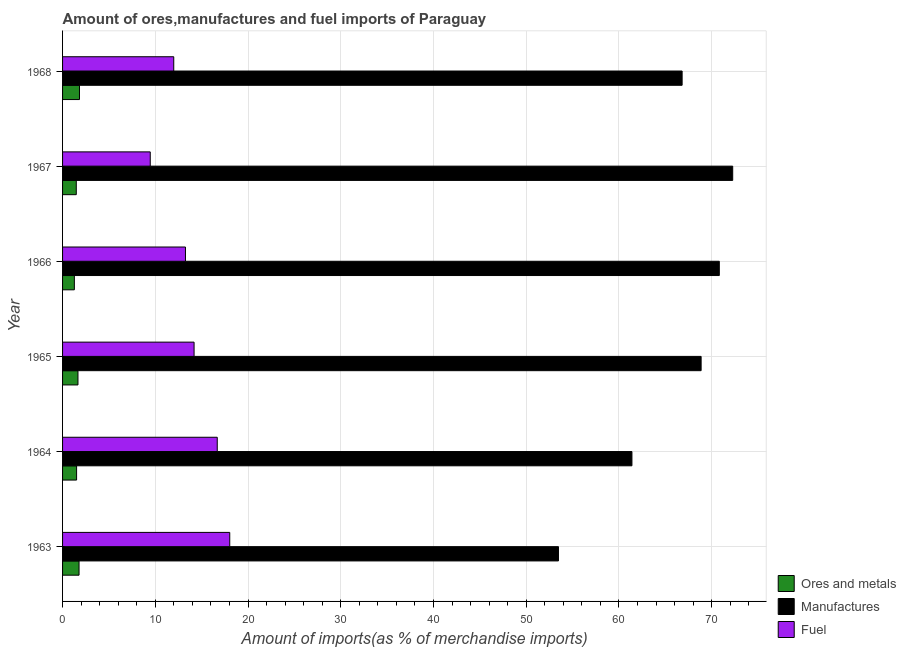Are the number of bars on each tick of the Y-axis equal?
Provide a short and direct response. Yes. How many bars are there on the 2nd tick from the top?
Make the answer very short. 3. What is the label of the 1st group of bars from the top?
Provide a succinct answer. 1968. In how many cases, is the number of bars for a given year not equal to the number of legend labels?
Offer a very short reply. 0. What is the percentage of manufactures imports in 1964?
Provide a short and direct response. 61.4. Across all years, what is the maximum percentage of ores and metals imports?
Your response must be concise. 1.82. Across all years, what is the minimum percentage of manufactures imports?
Provide a short and direct response. 53.48. In which year was the percentage of ores and metals imports maximum?
Provide a short and direct response. 1968. In which year was the percentage of manufactures imports minimum?
Provide a short and direct response. 1963. What is the total percentage of fuel imports in the graph?
Provide a succinct answer. 83.59. What is the difference between the percentage of manufactures imports in 1963 and that in 1967?
Offer a terse response. -18.79. What is the difference between the percentage of fuel imports in 1963 and the percentage of ores and metals imports in 1967?
Give a very brief answer. 16.55. What is the average percentage of fuel imports per year?
Offer a very short reply. 13.93. In the year 1968, what is the difference between the percentage of manufactures imports and percentage of fuel imports?
Your answer should be compact. 54.83. In how many years, is the percentage of manufactures imports greater than 32 %?
Offer a very short reply. 6. What is the ratio of the percentage of ores and metals imports in 1966 to that in 1967?
Offer a terse response. 0.86. Is the difference between the percentage of fuel imports in 1966 and 1968 greater than the difference between the percentage of manufactures imports in 1966 and 1968?
Offer a very short reply. No. What is the difference between the highest and the second highest percentage of ores and metals imports?
Ensure brevity in your answer.  0.05. What is the difference between the highest and the lowest percentage of ores and metals imports?
Your answer should be compact. 0.55. In how many years, is the percentage of fuel imports greater than the average percentage of fuel imports taken over all years?
Give a very brief answer. 3. Is the sum of the percentage of ores and metals imports in 1966 and 1967 greater than the maximum percentage of manufactures imports across all years?
Your answer should be very brief. No. What does the 3rd bar from the top in 1965 represents?
Give a very brief answer. Ores and metals. What does the 2nd bar from the bottom in 1968 represents?
Your answer should be compact. Manufactures. Is it the case that in every year, the sum of the percentage of ores and metals imports and percentage of manufactures imports is greater than the percentage of fuel imports?
Provide a short and direct response. Yes. What is the difference between two consecutive major ticks on the X-axis?
Provide a succinct answer. 10. Does the graph contain grids?
Ensure brevity in your answer.  Yes. Where does the legend appear in the graph?
Provide a short and direct response. Bottom right. How many legend labels are there?
Keep it short and to the point. 3. How are the legend labels stacked?
Ensure brevity in your answer.  Vertical. What is the title of the graph?
Offer a very short reply. Amount of ores,manufactures and fuel imports of Paraguay. Does "Grants" appear as one of the legend labels in the graph?
Keep it short and to the point. No. What is the label or title of the X-axis?
Give a very brief answer. Amount of imports(as % of merchandise imports). What is the label or title of the Y-axis?
Provide a short and direct response. Year. What is the Amount of imports(as % of merchandise imports) of Ores and metals in 1963?
Your response must be concise. 1.78. What is the Amount of imports(as % of merchandise imports) in Manufactures in 1963?
Ensure brevity in your answer.  53.48. What is the Amount of imports(as % of merchandise imports) of Fuel in 1963?
Ensure brevity in your answer.  18.03. What is the Amount of imports(as % of merchandise imports) of Ores and metals in 1964?
Your answer should be very brief. 1.51. What is the Amount of imports(as % of merchandise imports) of Manufactures in 1964?
Provide a short and direct response. 61.4. What is the Amount of imports(as % of merchandise imports) of Fuel in 1964?
Your answer should be compact. 16.68. What is the Amount of imports(as % of merchandise imports) in Ores and metals in 1965?
Provide a short and direct response. 1.66. What is the Amount of imports(as % of merchandise imports) in Manufactures in 1965?
Keep it short and to the point. 68.86. What is the Amount of imports(as % of merchandise imports) in Fuel in 1965?
Make the answer very short. 14.18. What is the Amount of imports(as % of merchandise imports) in Ores and metals in 1966?
Keep it short and to the point. 1.27. What is the Amount of imports(as % of merchandise imports) in Manufactures in 1966?
Keep it short and to the point. 70.83. What is the Amount of imports(as % of merchandise imports) of Fuel in 1966?
Provide a short and direct response. 13.25. What is the Amount of imports(as % of merchandise imports) of Ores and metals in 1967?
Offer a very short reply. 1.48. What is the Amount of imports(as % of merchandise imports) in Manufactures in 1967?
Offer a very short reply. 72.27. What is the Amount of imports(as % of merchandise imports) of Fuel in 1967?
Give a very brief answer. 9.46. What is the Amount of imports(as % of merchandise imports) in Ores and metals in 1968?
Your answer should be very brief. 1.82. What is the Amount of imports(as % of merchandise imports) in Manufactures in 1968?
Make the answer very short. 66.82. What is the Amount of imports(as % of merchandise imports) in Fuel in 1968?
Ensure brevity in your answer.  11.99. Across all years, what is the maximum Amount of imports(as % of merchandise imports) in Ores and metals?
Ensure brevity in your answer.  1.82. Across all years, what is the maximum Amount of imports(as % of merchandise imports) in Manufactures?
Provide a succinct answer. 72.27. Across all years, what is the maximum Amount of imports(as % of merchandise imports) of Fuel?
Make the answer very short. 18.03. Across all years, what is the minimum Amount of imports(as % of merchandise imports) of Ores and metals?
Offer a terse response. 1.27. Across all years, what is the minimum Amount of imports(as % of merchandise imports) of Manufactures?
Your response must be concise. 53.48. Across all years, what is the minimum Amount of imports(as % of merchandise imports) of Fuel?
Offer a very short reply. 9.46. What is the total Amount of imports(as % of merchandise imports) in Ores and metals in the graph?
Keep it short and to the point. 9.53. What is the total Amount of imports(as % of merchandise imports) in Manufactures in the graph?
Your answer should be compact. 393.66. What is the total Amount of imports(as % of merchandise imports) of Fuel in the graph?
Keep it short and to the point. 83.59. What is the difference between the Amount of imports(as % of merchandise imports) in Ores and metals in 1963 and that in 1964?
Keep it short and to the point. 0.26. What is the difference between the Amount of imports(as % of merchandise imports) in Manufactures in 1963 and that in 1964?
Offer a terse response. -7.92. What is the difference between the Amount of imports(as % of merchandise imports) in Fuel in 1963 and that in 1964?
Your answer should be very brief. 1.35. What is the difference between the Amount of imports(as % of merchandise imports) in Ores and metals in 1963 and that in 1965?
Offer a very short reply. 0.12. What is the difference between the Amount of imports(as % of merchandise imports) of Manufactures in 1963 and that in 1965?
Offer a very short reply. -15.38. What is the difference between the Amount of imports(as % of merchandise imports) of Fuel in 1963 and that in 1965?
Your answer should be compact. 3.85. What is the difference between the Amount of imports(as % of merchandise imports) of Ores and metals in 1963 and that in 1966?
Give a very brief answer. 0.5. What is the difference between the Amount of imports(as % of merchandise imports) in Manufactures in 1963 and that in 1966?
Your answer should be compact. -17.35. What is the difference between the Amount of imports(as % of merchandise imports) in Fuel in 1963 and that in 1966?
Your response must be concise. 4.78. What is the difference between the Amount of imports(as % of merchandise imports) in Ores and metals in 1963 and that in 1967?
Make the answer very short. 0.3. What is the difference between the Amount of imports(as % of merchandise imports) of Manufactures in 1963 and that in 1967?
Keep it short and to the point. -18.79. What is the difference between the Amount of imports(as % of merchandise imports) of Fuel in 1963 and that in 1967?
Offer a very short reply. 8.57. What is the difference between the Amount of imports(as % of merchandise imports) in Ores and metals in 1963 and that in 1968?
Keep it short and to the point. -0.05. What is the difference between the Amount of imports(as % of merchandise imports) of Manufactures in 1963 and that in 1968?
Offer a terse response. -13.34. What is the difference between the Amount of imports(as % of merchandise imports) of Fuel in 1963 and that in 1968?
Your response must be concise. 6.04. What is the difference between the Amount of imports(as % of merchandise imports) of Ores and metals in 1964 and that in 1965?
Your answer should be compact. -0.15. What is the difference between the Amount of imports(as % of merchandise imports) in Manufactures in 1964 and that in 1965?
Offer a terse response. -7.46. What is the difference between the Amount of imports(as % of merchandise imports) in Fuel in 1964 and that in 1965?
Your answer should be very brief. 2.5. What is the difference between the Amount of imports(as % of merchandise imports) of Ores and metals in 1964 and that in 1966?
Offer a very short reply. 0.24. What is the difference between the Amount of imports(as % of merchandise imports) of Manufactures in 1964 and that in 1966?
Make the answer very short. -9.42. What is the difference between the Amount of imports(as % of merchandise imports) of Fuel in 1964 and that in 1966?
Offer a terse response. 3.43. What is the difference between the Amount of imports(as % of merchandise imports) in Ores and metals in 1964 and that in 1967?
Your answer should be very brief. 0.03. What is the difference between the Amount of imports(as % of merchandise imports) in Manufactures in 1964 and that in 1967?
Your response must be concise. -10.87. What is the difference between the Amount of imports(as % of merchandise imports) of Fuel in 1964 and that in 1967?
Keep it short and to the point. 7.23. What is the difference between the Amount of imports(as % of merchandise imports) of Ores and metals in 1964 and that in 1968?
Keep it short and to the point. -0.31. What is the difference between the Amount of imports(as % of merchandise imports) of Manufactures in 1964 and that in 1968?
Provide a short and direct response. -5.41. What is the difference between the Amount of imports(as % of merchandise imports) in Fuel in 1964 and that in 1968?
Ensure brevity in your answer.  4.69. What is the difference between the Amount of imports(as % of merchandise imports) in Ores and metals in 1965 and that in 1966?
Your answer should be very brief. 0.39. What is the difference between the Amount of imports(as % of merchandise imports) of Manufactures in 1965 and that in 1966?
Offer a terse response. -1.96. What is the difference between the Amount of imports(as % of merchandise imports) of Fuel in 1965 and that in 1966?
Ensure brevity in your answer.  0.93. What is the difference between the Amount of imports(as % of merchandise imports) in Ores and metals in 1965 and that in 1967?
Provide a short and direct response. 0.18. What is the difference between the Amount of imports(as % of merchandise imports) of Manufactures in 1965 and that in 1967?
Ensure brevity in your answer.  -3.41. What is the difference between the Amount of imports(as % of merchandise imports) in Fuel in 1965 and that in 1967?
Your response must be concise. 4.73. What is the difference between the Amount of imports(as % of merchandise imports) of Ores and metals in 1965 and that in 1968?
Make the answer very short. -0.16. What is the difference between the Amount of imports(as % of merchandise imports) of Manufactures in 1965 and that in 1968?
Offer a very short reply. 2.05. What is the difference between the Amount of imports(as % of merchandise imports) of Fuel in 1965 and that in 1968?
Ensure brevity in your answer.  2.19. What is the difference between the Amount of imports(as % of merchandise imports) of Ores and metals in 1966 and that in 1967?
Provide a succinct answer. -0.21. What is the difference between the Amount of imports(as % of merchandise imports) of Manufactures in 1966 and that in 1967?
Make the answer very short. -1.44. What is the difference between the Amount of imports(as % of merchandise imports) in Fuel in 1966 and that in 1967?
Make the answer very short. 3.8. What is the difference between the Amount of imports(as % of merchandise imports) of Ores and metals in 1966 and that in 1968?
Offer a very short reply. -0.55. What is the difference between the Amount of imports(as % of merchandise imports) of Manufactures in 1966 and that in 1968?
Provide a succinct answer. 4.01. What is the difference between the Amount of imports(as % of merchandise imports) in Fuel in 1966 and that in 1968?
Your answer should be compact. 1.26. What is the difference between the Amount of imports(as % of merchandise imports) in Ores and metals in 1967 and that in 1968?
Give a very brief answer. -0.35. What is the difference between the Amount of imports(as % of merchandise imports) of Manufactures in 1967 and that in 1968?
Provide a succinct answer. 5.45. What is the difference between the Amount of imports(as % of merchandise imports) of Fuel in 1967 and that in 1968?
Provide a succinct answer. -2.53. What is the difference between the Amount of imports(as % of merchandise imports) in Ores and metals in 1963 and the Amount of imports(as % of merchandise imports) in Manufactures in 1964?
Your response must be concise. -59.63. What is the difference between the Amount of imports(as % of merchandise imports) of Ores and metals in 1963 and the Amount of imports(as % of merchandise imports) of Fuel in 1964?
Your response must be concise. -14.9. What is the difference between the Amount of imports(as % of merchandise imports) in Manufactures in 1963 and the Amount of imports(as % of merchandise imports) in Fuel in 1964?
Give a very brief answer. 36.8. What is the difference between the Amount of imports(as % of merchandise imports) in Ores and metals in 1963 and the Amount of imports(as % of merchandise imports) in Manufactures in 1965?
Provide a succinct answer. -67.09. What is the difference between the Amount of imports(as % of merchandise imports) in Ores and metals in 1963 and the Amount of imports(as % of merchandise imports) in Fuel in 1965?
Your answer should be very brief. -12.41. What is the difference between the Amount of imports(as % of merchandise imports) in Manufactures in 1963 and the Amount of imports(as % of merchandise imports) in Fuel in 1965?
Offer a terse response. 39.3. What is the difference between the Amount of imports(as % of merchandise imports) of Ores and metals in 1963 and the Amount of imports(as % of merchandise imports) of Manufactures in 1966?
Provide a short and direct response. -69.05. What is the difference between the Amount of imports(as % of merchandise imports) of Ores and metals in 1963 and the Amount of imports(as % of merchandise imports) of Fuel in 1966?
Your answer should be compact. -11.48. What is the difference between the Amount of imports(as % of merchandise imports) in Manufactures in 1963 and the Amount of imports(as % of merchandise imports) in Fuel in 1966?
Make the answer very short. 40.23. What is the difference between the Amount of imports(as % of merchandise imports) of Ores and metals in 1963 and the Amount of imports(as % of merchandise imports) of Manufactures in 1967?
Your response must be concise. -70.49. What is the difference between the Amount of imports(as % of merchandise imports) of Ores and metals in 1963 and the Amount of imports(as % of merchandise imports) of Fuel in 1967?
Your response must be concise. -7.68. What is the difference between the Amount of imports(as % of merchandise imports) in Manufactures in 1963 and the Amount of imports(as % of merchandise imports) in Fuel in 1967?
Offer a very short reply. 44.03. What is the difference between the Amount of imports(as % of merchandise imports) of Ores and metals in 1963 and the Amount of imports(as % of merchandise imports) of Manufactures in 1968?
Your answer should be compact. -65.04. What is the difference between the Amount of imports(as % of merchandise imports) in Ores and metals in 1963 and the Amount of imports(as % of merchandise imports) in Fuel in 1968?
Offer a very short reply. -10.21. What is the difference between the Amount of imports(as % of merchandise imports) of Manufactures in 1963 and the Amount of imports(as % of merchandise imports) of Fuel in 1968?
Keep it short and to the point. 41.49. What is the difference between the Amount of imports(as % of merchandise imports) of Ores and metals in 1964 and the Amount of imports(as % of merchandise imports) of Manufactures in 1965?
Make the answer very short. -67.35. What is the difference between the Amount of imports(as % of merchandise imports) of Ores and metals in 1964 and the Amount of imports(as % of merchandise imports) of Fuel in 1965?
Your response must be concise. -12.67. What is the difference between the Amount of imports(as % of merchandise imports) of Manufactures in 1964 and the Amount of imports(as % of merchandise imports) of Fuel in 1965?
Provide a short and direct response. 47.22. What is the difference between the Amount of imports(as % of merchandise imports) of Ores and metals in 1964 and the Amount of imports(as % of merchandise imports) of Manufactures in 1966?
Your answer should be compact. -69.31. What is the difference between the Amount of imports(as % of merchandise imports) of Ores and metals in 1964 and the Amount of imports(as % of merchandise imports) of Fuel in 1966?
Your answer should be compact. -11.74. What is the difference between the Amount of imports(as % of merchandise imports) in Manufactures in 1964 and the Amount of imports(as % of merchandise imports) in Fuel in 1966?
Keep it short and to the point. 48.15. What is the difference between the Amount of imports(as % of merchandise imports) in Ores and metals in 1964 and the Amount of imports(as % of merchandise imports) in Manufactures in 1967?
Make the answer very short. -70.76. What is the difference between the Amount of imports(as % of merchandise imports) of Ores and metals in 1964 and the Amount of imports(as % of merchandise imports) of Fuel in 1967?
Your answer should be compact. -7.94. What is the difference between the Amount of imports(as % of merchandise imports) of Manufactures in 1964 and the Amount of imports(as % of merchandise imports) of Fuel in 1967?
Offer a terse response. 51.95. What is the difference between the Amount of imports(as % of merchandise imports) of Ores and metals in 1964 and the Amount of imports(as % of merchandise imports) of Manufactures in 1968?
Your response must be concise. -65.3. What is the difference between the Amount of imports(as % of merchandise imports) in Ores and metals in 1964 and the Amount of imports(as % of merchandise imports) in Fuel in 1968?
Provide a short and direct response. -10.48. What is the difference between the Amount of imports(as % of merchandise imports) in Manufactures in 1964 and the Amount of imports(as % of merchandise imports) in Fuel in 1968?
Ensure brevity in your answer.  49.41. What is the difference between the Amount of imports(as % of merchandise imports) in Ores and metals in 1965 and the Amount of imports(as % of merchandise imports) in Manufactures in 1966?
Ensure brevity in your answer.  -69.17. What is the difference between the Amount of imports(as % of merchandise imports) in Ores and metals in 1965 and the Amount of imports(as % of merchandise imports) in Fuel in 1966?
Provide a succinct answer. -11.59. What is the difference between the Amount of imports(as % of merchandise imports) of Manufactures in 1965 and the Amount of imports(as % of merchandise imports) of Fuel in 1966?
Give a very brief answer. 55.61. What is the difference between the Amount of imports(as % of merchandise imports) of Ores and metals in 1965 and the Amount of imports(as % of merchandise imports) of Manufactures in 1967?
Provide a succinct answer. -70.61. What is the difference between the Amount of imports(as % of merchandise imports) of Ores and metals in 1965 and the Amount of imports(as % of merchandise imports) of Fuel in 1967?
Keep it short and to the point. -7.8. What is the difference between the Amount of imports(as % of merchandise imports) of Manufactures in 1965 and the Amount of imports(as % of merchandise imports) of Fuel in 1967?
Provide a short and direct response. 59.41. What is the difference between the Amount of imports(as % of merchandise imports) in Ores and metals in 1965 and the Amount of imports(as % of merchandise imports) in Manufactures in 1968?
Provide a succinct answer. -65.16. What is the difference between the Amount of imports(as % of merchandise imports) in Ores and metals in 1965 and the Amount of imports(as % of merchandise imports) in Fuel in 1968?
Your response must be concise. -10.33. What is the difference between the Amount of imports(as % of merchandise imports) of Manufactures in 1965 and the Amount of imports(as % of merchandise imports) of Fuel in 1968?
Provide a succinct answer. 56.87. What is the difference between the Amount of imports(as % of merchandise imports) in Ores and metals in 1966 and the Amount of imports(as % of merchandise imports) in Manufactures in 1967?
Offer a very short reply. -71. What is the difference between the Amount of imports(as % of merchandise imports) in Ores and metals in 1966 and the Amount of imports(as % of merchandise imports) in Fuel in 1967?
Ensure brevity in your answer.  -8.18. What is the difference between the Amount of imports(as % of merchandise imports) of Manufactures in 1966 and the Amount of imports(as % of merchandise imports) of Fuel in 1967?
Provide a short and direct response. 61.37. What is the difference between the Amount of imports(as % of merchandise imports) of Ores and metals in 1966 and the Amount of imports(as % of merchandise imports) of Manufactures in 1968?
Your answer should be very brief. -65.54. What is the difference between the Amount of imports(as % of merchandise imports) of Ores and metals in 1966 and the Amount of imports(as % of merchandise imports) of Fuel in 1968?
Your response must be concise. -10.72. What is the difference between the Amount of imports(as % of merchandise imports) in Manufactures in 1966 and the Amount of imports(as % of merchandise imports) in Fuel in 1968?
Your answer should be compact. 58.84. What is the difference between the Amount of imports(as % of merchandise imports) of Ores and metals in 1967 and the Amount of imports(as % of merchandise imports) of Manufactures in 1968?
Your response must be concise. -65.34. What is the difference between the Amount of imports(as % of merchandise imports) in Ores and metals in 1967 and the Amount of imports(as % of merchandise imports) in Fuel in 1968?
Keep it short and to the point. -10.51. What is the difference between the Amount of imports(as % of merchandise imports) in Manufactures in 1967 and the Amount of imports(as % of merchandise imports) in Fuel in 1968?
Ensure brevity in your answer.  60.28. What is the average Amount of imports(as % of merchandise imports) in Ores and metals per year?
Provide a short and direct response. 1.59. What is the average Amount of imports(as % of merchandise imports) of Manufactures per year?
Give a very brief answer. 65.61. What is the average Amount of imports(as % of merchandise imports) in Fuel per year?
Offer a very short reply. 13.93. In the year 1963, what is the difference between the Amount of imports(as % of merchandise imports) of Ores and metals and Amount of imports(as % of merchandise imports) of Manufactures?
Provide a succinct answer. -51.7. In the year 1963, what is the difference between the Amount of imports(as % of merchandise imports) in Ores and metals and Amount of imports(as % of merchandise imports) in Fuel?
Provide a succinct answer. -16.25. In the year 1963, what is the difference between the Amount of imports(as % of merchandise imports) of Manufactures and Amount of imports(as % of merchandise imports) of Fuel?
Offer a terse response. 35.45. In the year 1964, what is the difference between the Amount of imports(as % of merchandise imports) of Ores and metals and Amount of imports(as % of merchandise imports) of Manufactures?
Offer a terse response. -59.89. In the year 1964, what is the difference between the Amount of imports(as % of merchandise imports) of Ores and metals and Amount of imports(as % of merchandise imports) of Fuel?
Provide a succinct answer. -15.17. In the year 1964, what is the difference between the Amount of imports(as % of merchandise imports) of Manufactures and Amount of imports(as % of merchandise imports) of Fuel?
Offer a terse response. 44.72. In the year 1965, what is the difference between the Amount of imports(as % of merchandise imports) in Ores and metals and Amount of imports(as % of merchandise imports) in Manufactures?
Provide a short and direct response. -67.2. In the year 1965, what is the difference between the Amount of imports(as % of merchandise imports) of Ores and metals and Amount of imports(as % of merchandise imports) of Fuel?
Provide a succinct answer. -12.52. In the year 1965, what is the difference between the Amount of imports(as % of merchandise imports) of Manufactures and Amount of imports(as % of merchandise imports) of Fuel?
Your answer should be very brief. 54.68. In the year 1966, what is the difference between the Amount of imports(as % of merchandise imports) in Ores and metals and Amount of imports(as % of merchandise imports) in Manufactures?
Keep it short and to the point. -69.55. In the year 1966, what is the difference between the Amount of imports(as % of merchandise imports) of Ores and metals and Amount of imports(as % of merchandise imports) of Fuel?
Keep it short and to the point. -11.98. In the year 1966, what is the difference between the Amount of imports(as % of merchandise imports) of Manufactures and Amount of imports(as % of merchandise imports) of Fuel?
Keep it short and to the point. 57.57. In the year 1967, what is the difference between the Amount of imports(as % of merchandise imports) in Ores and metals and Amount of imports(as % of merchandise imports) in Manufactures?
Offer a very short reply. -70.79. In the year 1967, what is the difference between the Amount of imports(as % of merchandise imports) in Ores and metals and Amount of imports(as % of merchandise imports) in Fuel?
Your answer should be very brief. -7.98. In the year 1967, what is the difference between the Amount of imports(as % of merchandise imports) of Manufactures and Amount of imports(as % of merchandise imports) of Fuel?
Your answer should be compact. 62.82. In the year 1968, what is the difference between the Amount of imports(as % of merchandise imports) of Ores and metals and Amount of imports(as % of merchandise imports) of Manufactures?
Keep it short and to the point. -64.99. In the year 1968, what is the difference between the Amount of imports(as % of merchandise imports) of Ores and metals and Amount of imports(as % of merchandise imports) of Fuel?
Offer a terse response. -10.16. In the year 1968, what is the difference between the Amount of imports(as % of merchandise imports) in Manufactures and Amount of imports(as % of merchandise imports) in Fuel?
Your answer should be very brief. 54.83. What is the ratio of the Amount of imports(as % of merchandise imports) in Ores and metals in 1963 to that in 1964?
Provide a succinct answer. 1.18. What is the ratio of the Amount of imports(as % of merchandise imports) in Manufactures in 1963 to that in 1964?
Provide a short and direct response. 0.87. What is the ratio of the Amount of imports(as % of merchandise imports) of Fuel in 1963 to that in 1964?
Ensure brevity in your answer.  1.08. What is the ratio of the Amount of imports(as % of merchandise imports) in Ores and metals in 1963 to that in 1965?
Give a very brief answer. 1.07. What is the ratio of the Amount of imports(as % of merchandise imports) in Manufactures in 1963 to that in 1965?
Offer a very short reply. 0.78. What is the ratio of the Amount of imports(as % of merchandise imports) in Fuel in 1963 to that in 1965?
Your answer should be compact. 1.27. What is the ratio of the Amount of imports(as % of merchandise imports) in Ores and metals in 1963 to that in 1966?
Keep it short and to the point. 1.4. What is the ratio of the Amount of imports(as % of merchandise imports) of Manufactures in 1963 to that in 1966?
Keep it short and to the point. 0.76. What is the ratio of the Amount of imports(as % of merchandise imports) in Fuel in 1963 to that in 1966?
Give a very brief answer. 1.36. What is the ratio of the Amount of imports(as % of merchandise imports) of Ores and metals in 1963 to that in 1967?
Your answer should be compact. 1.2. What is the ratio of the Amount of imports(as % of merchandise imports) of Manufactures in 1963 to that in 1967?
Your answer should be very brief. 0.74. What is the ratio of the Amount of imports(as % of merchandise imports) of Fuel in 1963 to that in 1967?
Offer a terse response. 1.91. What is the ratio of the Amount of imports(as % of merchandise imports) of Ores and metals in 1963 to that in 1968?
Keep it short and to the point. 0.97. What is the ratio of the Amount of imports(as % of merchandise imports) in Manufactures in 1963 to that in 1968?
Give a very brief answer. 0.8. What is the ratio of the Amount of imports(as % of merchandise imports) of Fuel in 1963 to that in 1968?
Provide a succinct answer. 1.5. What is the ratio of the Amount of imports(as % of merchandise imports) in Ores and metals in 1964 to that in 1965?
Provide a short and direct response. 0.91. What is the ratio of the Amount of imports(as % of merchandise imports) of Manufactures in 1964 to that in 1965?
Give a very brief answer. 0.89. What is the ratio of the Amount of imports(as % of merchandise imports) of Fuel in 1964 to that in 1965?
Provide a short and direct response. 1.18. What is the ratio of the Amount of imports(as % of merchandise imports) of Ores and metals in 1964 to that in 1966?
Your answer should be very brief. 1.19. What is the ratio of the Amount of imports(as % of merchandise imports) of Manufactures in 1964 to that in 1966?
Your answer should be very brief. 0.87. What is the ratio of the Amount of imports(as % of merchandise imports) in Fuel in 1964 to that in 1966?
Ensure brevity in your answer.  1.26. What is the ratio of the Amount of imports(as % of merchandise imports) of Ores and metals in 1964 to that in 1967?
Your response must be concise. 1.02. What is the ratio of the Amount of imports(as % of merchandise imports) of Manufactures in 1964 to that in 1967?
Make the answer very short. 0.85. What is the ratio of the Amount of imports(as % of merchandise imports) of Fuel in 1964 to that in 1967?
Your answer should be compact. 1.76. What is the ratio of the Amount of imports(as % of merchandise imports) in Ores and metals in 1964 to that in 1968?
Provide a succinct answer. 0.83. What is the ratio of the Amount of imports(as % of merchandise imports) in Manufactures in 1964 to that in 1968?
Provide a short and direct response. 0.92. What is the ratio of the Amount of imports(as % of merchandise imports) of Fuel in 1964 to that in 1968?
Offer a very short reply. 1.39. What is the ratio of the Amount of imports(as % of merchandise imports) of Ores and metals in 1965 to that in 1966?
Offer a terse response. 1.31. What is the ratio of the Amount of imports(as % of merchandise imports) of Manufactures in 1965 to that in 1966?
Keep it short and to the point. 0.97. What is the ratio of the Amount of imports(as % of merchandise imports) in Fuel in 1965 to that in 1966?
Offer a terse response. 1.07. What is the ratio of the Amount of imports(as % of merchandise imports) of Ores and metals in 1965 to that in 1967?
Your answer should be compact. 1.12. What is the ratio of the Amount of imports(as % of merchandise imports) of Manufactures in 1965 to that in 1967?
Provide a succinct answer. 0.95. What is the ratio of the Amount of imports(as % of merchandise imports) in Fuel in 1965 to that in 1967?
Make the answer very short. 1.5. What is the ratio of the Amount of imports(as % of merchandise imports) of Ores and metals in 1965 to that in 1968?
Ensure brevity in your answer.  0.91. What is the ratio of the Amount of imports(as % of merchandise imports) in Manufactures in 1965 to that in 1968?
Offer a very short reply. 1.03. What is the ratio of the Amount of imports(as % of merchandise imports) in Fuel in 1965 to that in 1968?
Offer a very short reply. 1.18. What is the ratio of the Amount of imports(as % of merchandise imports) in Ores and metals in 1966 to that in 1967?
Your response must be concise. 0.86. What is the ratio of the Amount of imports(as % of merchandise imports) of Fuel in 1966 to that in 1967?
Provide a succinct answer. 1.4. What is the ratio of the Amount of imports(as % of merchandise imports) in Ores and metals in 1966 to that in 1968?
Your response must be concise. 0.7. What is the ratio of the Amount of imports(as % of merchandise imports) of Manufactures in 1966 to that in 1968?
Offer a terse response. 1.06. What is the ratio of the Amount of imports(as % of merchandise imports) of Fuel in 1966 to that in 1968?
Offer a terse response. 1.11. What is the ratio of the Amount of imports(as % of merchandise imports) of Ores and metals in 1967 to that in 1968?
Ensure brevity in your answer.  0.81. What is the ratio of the Amount of imports(as % of merchandise imports) of Manufactures in 1967 to that in 1968?
Your answer should be very brief. 1.08. What is the ratio of the Amount of imports(as % of merchandise imports) in Fuel in 1967 to that in 1968?
Offer a very short reply. 0.79. What is the difference between the highest and the second highest Amount of imports(as % of merchandise imports) of Ores and metals?
Your answer should be very brief. 0.05. What is the difference between the highest and the second highest Amount of imports(as % of merchandise imports) in Manufactures?
Offer a terse response. 1.44. What is the difference between the highest and the second highest Amount of imports(as % of merchandise imports) in Fuel?
Give a very brief answer. 1.35. What is the difference between the highest and the lowest Amount of imports(as % of merchandise imports) in Ores and metals?
Your response must be concise. 0.55. What is the difference between the highest and the lowest Amount of imports(as % of merchandise imports) of Manufactures?
Provide a succinct answer. 18.79. What is the difference between the highest and the lowest Amount of imports(as % of merchandise imports) of Fuel?
Your answer should be compact. 8.57. 